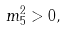<formula> <loc_0><loc_0><loc_500><loc_500>m _ { 5 } ^ { 2 } > 0 ,</formula> 